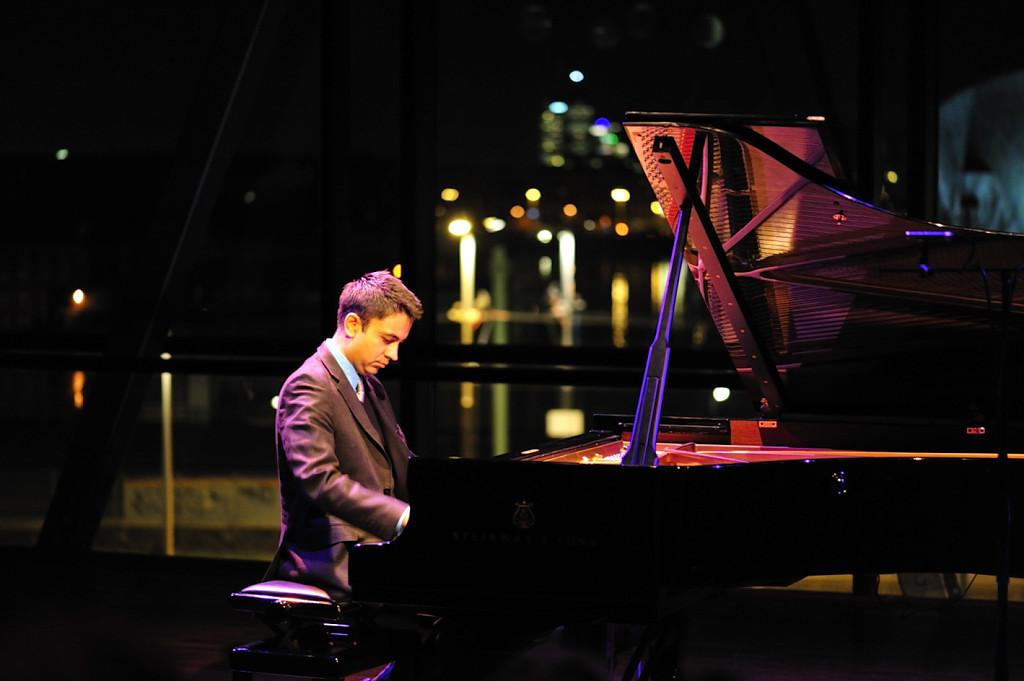What type of music instrument is in the image? There is a black color music instrument in the image. Who is present in the image? There is a man sitting in front of the music instrument. What is the color of the background in the image? The background of the image is black. What type of action is the tank performing in the image? There is no tank present in the image; it only features a black color music instrument and a man sitting in front of it. 